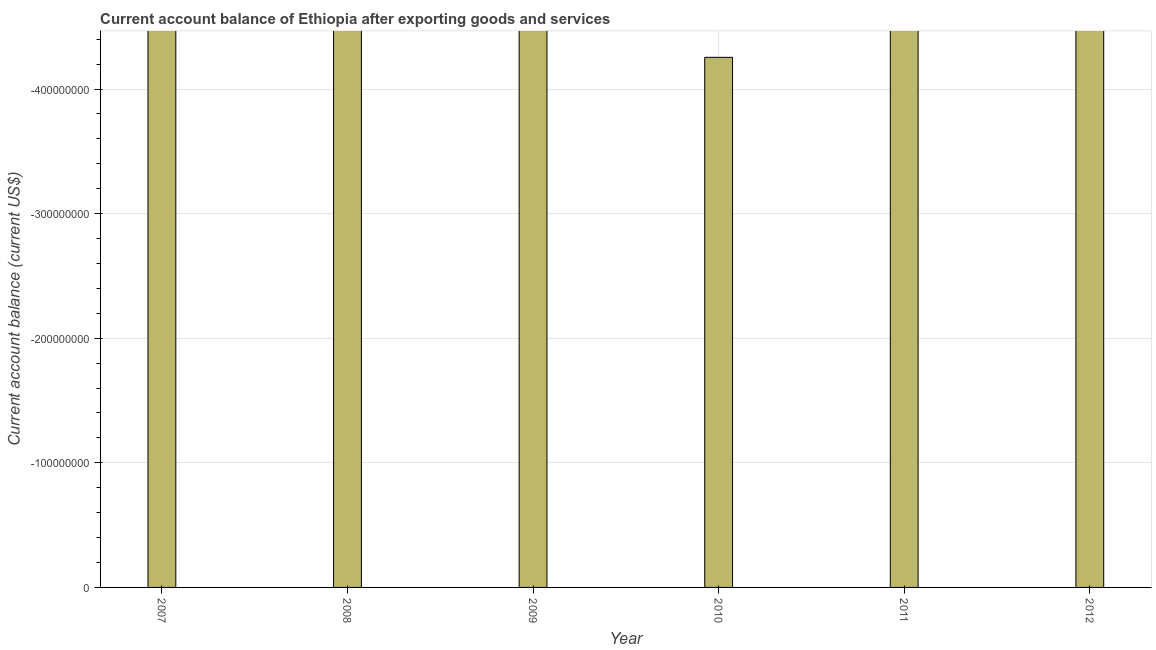Does the graph contain any zero values?
Offer a terse response. Yes. What is the title of the graph?
Make the answer very short. Current account balance of Ethiopia after exporting goods and services. What is the label or title of the X-axis?
Keep it short and to the point. Year. What is the label or title of the Y-axis?
Your response must be concise. Current account balance (current US$). What is the current account balance in 2010?
Give a very brief answer. 0. What is the sum of the current account balance?
Offer a terse response. 0. What is the median current account balance?
Provide a succinct answer. 0. In how many years, is the current account balance greater than -140000000 US$?
Give a very brief answer. 0. How many bars are there?
Make the answer very short. 0. How many years are there in the graph?
Provide a short and direct response. 6. What is the Current account balance (current US$) in 2008?
Provide a succinct answer. 0. What is the Current account balance (current US$) of 2010?
Your answer should be very brief. 0. What is the Current account balance (current US$) of 2012?
Your answer should be very brief. 0. 